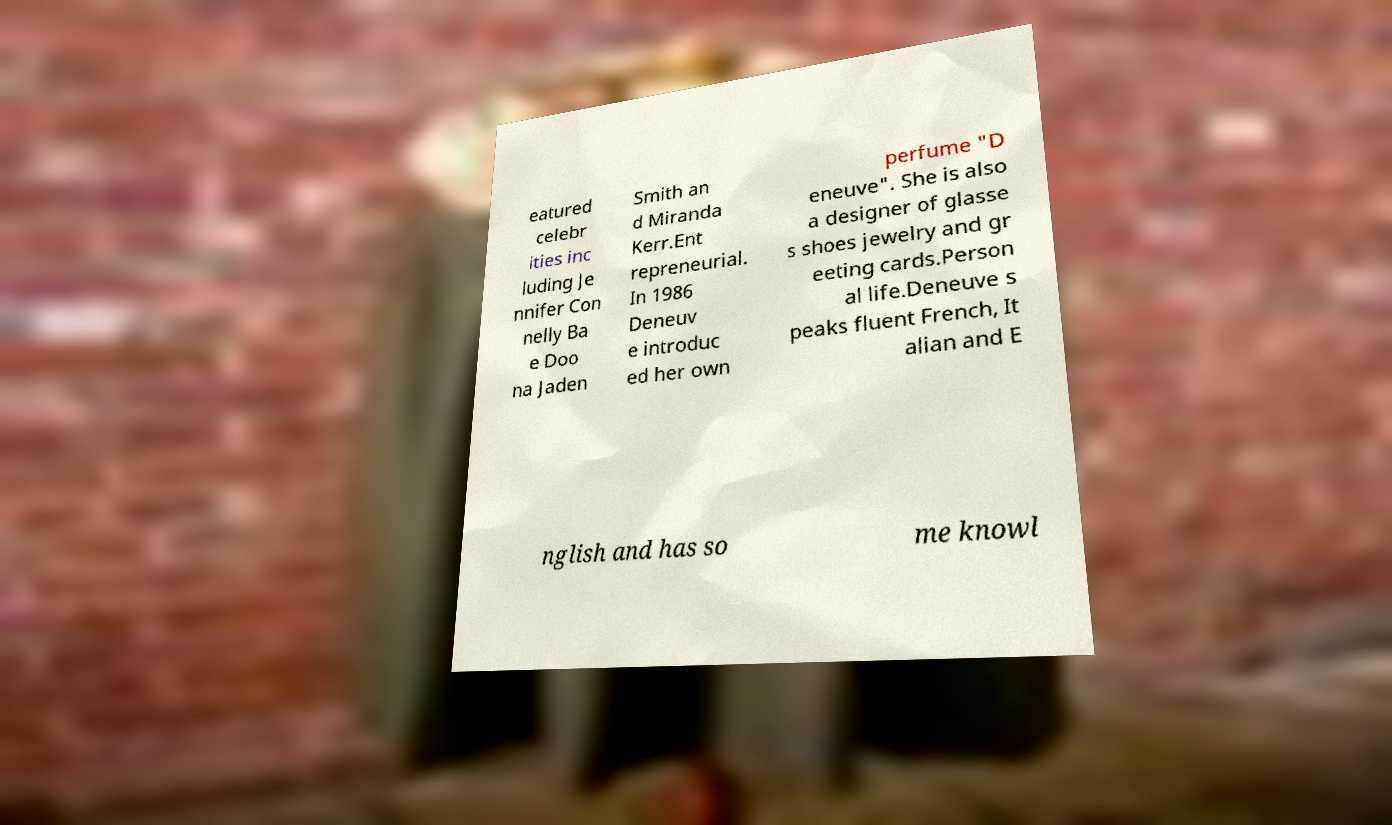I need the written content from this picture converted into text. Can you do that? eatured celebr ities inc luding Je nnifer Con nelly Ba e Doo na Jaden Smith an d Miranda Kerr.Ent repreneurial. In 1986 Deneuv e introduc ed her own perfume "D eneuve". She is also a designer of glasse s shoes jewelry and gr eeting cards.Person al life.Deneuve s peaks fluent French, It alian and E nglish and has so me knowl 